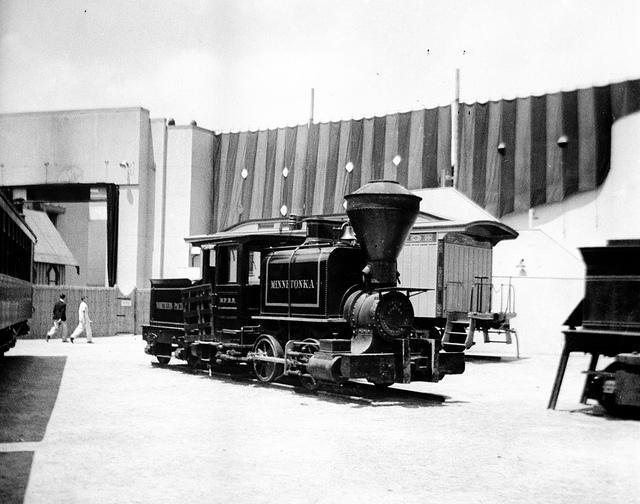How many people are there?
Give a very brief answer. 2. How many trains are there?
Give a very brief answer. 2. How many dogs are there?
Give a very brief answer. 0. 